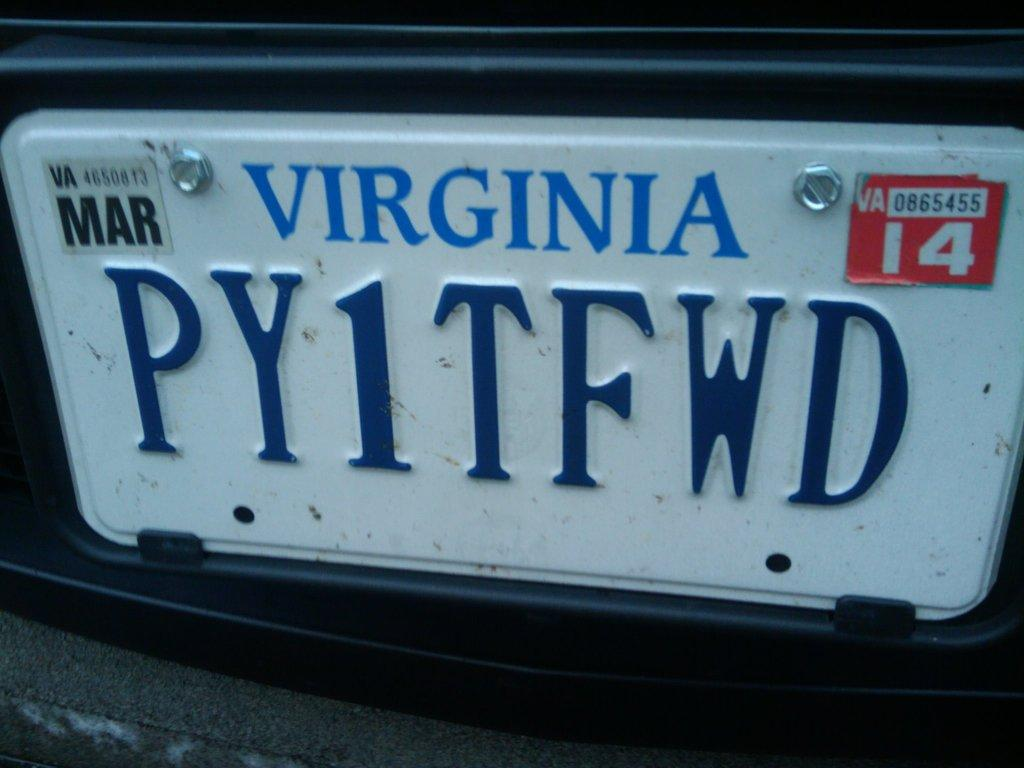<image>
Present a compact description of the photo's key features. A tag from Virginia that reads PY1TFWD and expires in March of 1 